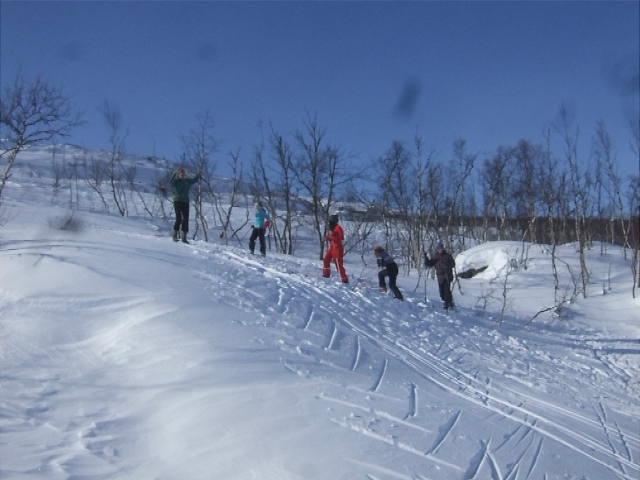Who is the man in red trying to reach? Please explain your reasoning. green jacket. The skier in the red jacket is trying to get to the top of the hill where the man in green is about to ski down. 